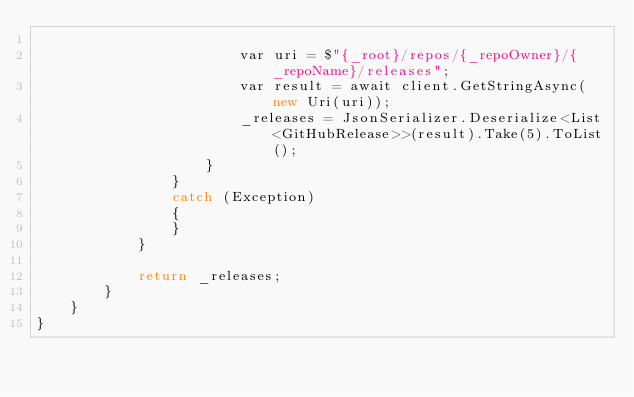<code> <loc_0><loc_0><loc_500><loc_500><_C#_>
                        var uri = $"{_root}/repos/{_repoOwner}/{_repoName}/releases";
                        var result = await client.GetStringAsync(new Uri(uri));
                        _releases = JsonSerializer.Deserialize<List<GitHubRelease>>(result).Take(5).ToList();
                    }
                }
                catch (Exception)
                {
                }
            }

            return _releases;
        }
    }
}</code> 